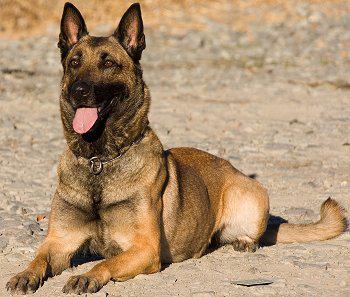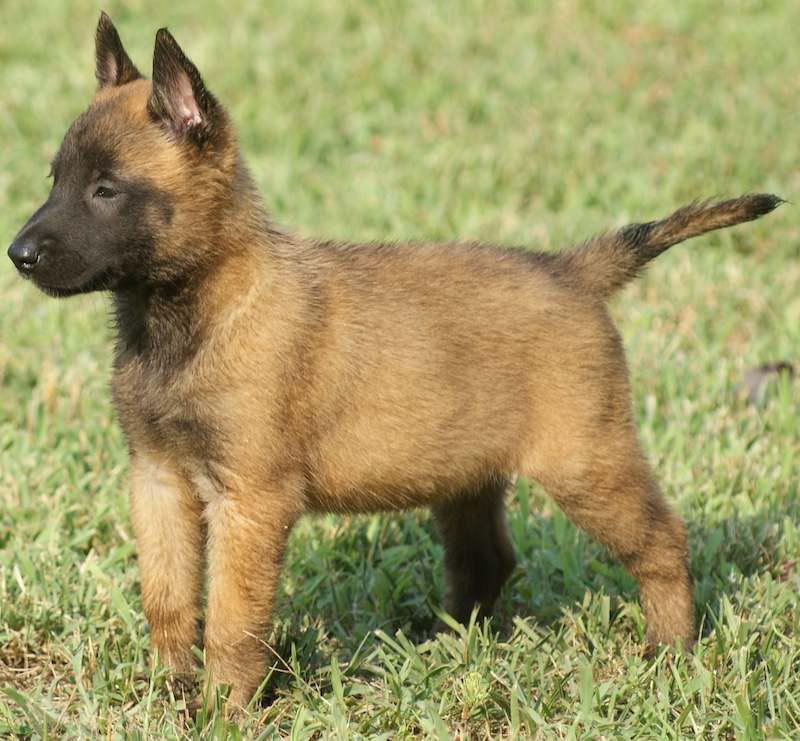The first image is the image on the left, the second image is the image on the right. Evaluate the accuracy of this statement regarding the images: "In one of the images, a dog is wearing a leash attached to a collar". Is it true? Answer yes or no. No. 